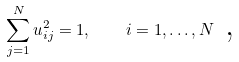Convert formula to latex. <formula><loc_0><loc_0><loc_500><loc_500>\sum _ { j = 1 } ^ { N } u _ { i j } ^ { 2 } = 1 , \quad i = 1 , \dots , N \text { ,}</formula> 